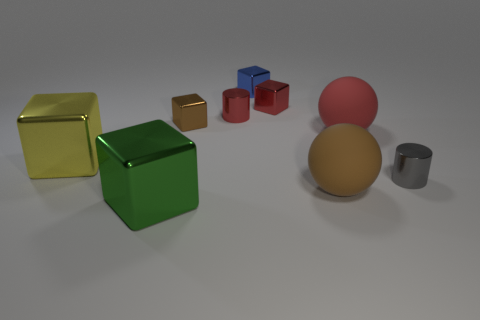Subtract 1 cubes. How many cubes are left? 4 Subtract all purple cubes. Subtract all purple cylinders. How many cubes are left? 5 Add 1 small green metallic cubes. How many objects exist? 10 Subtract all spheres. How many objects are left? 7 Subtract 0 green cylinders. How many objects are left? 9 Subtract all cyan objects. Subtract all gray metal cylinders. How many objects are left? 8 Add 8 small brown shiny objects. How many small brown shiny objects are left? 9 Add 7 small green metallic cylinders. How many small green metallic cylinders exist? 7 